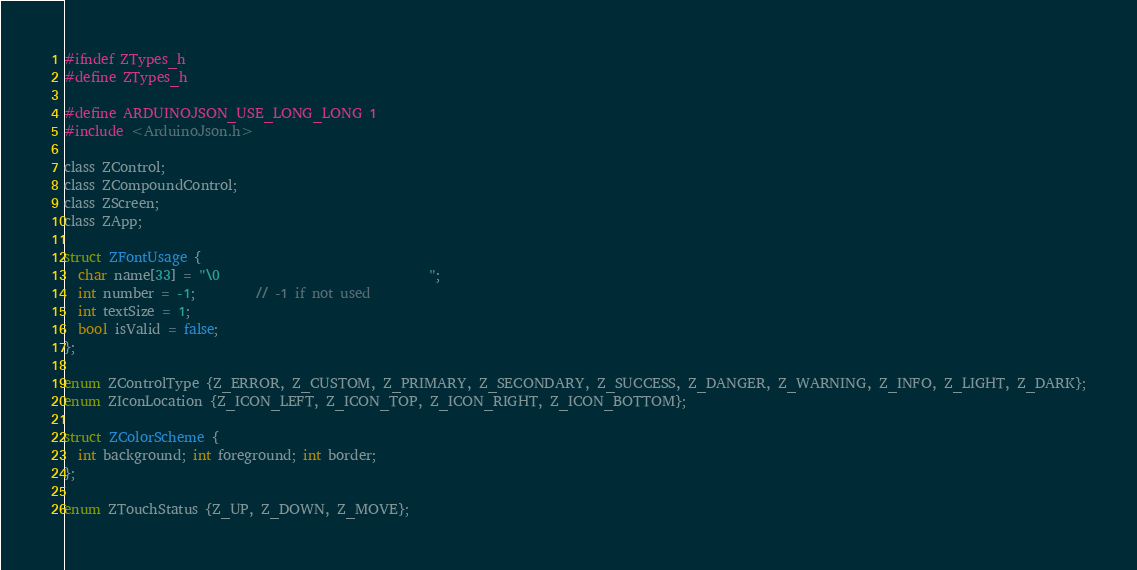<code> <loc_0><loc_0><loc_500><loc_500><_C_>#ifndef ZTypes_h
#define ZTypes_h

#define ARDUINOJSON_USE_LONG_LONG 1
#include <ArduinoJson.h>

class ZControl;
class ZCompoundControl;
class ZScreen;
class ZApp;

struct ZFontUsage {
  char name[33] = "\0                               ";
  int number = -1;         // -1 if not used
  int textSize = 1;
  bool isValid = false;
};

enum ZControlType {Z_ERROR, Z_CUSTOM, Z_PRIMARY, Z_SECONDARY, Z_SUCCESS, Z_DANGER, Z_WARNING, Z_INFO, Z_LIGHT, Z_DARK};
enum ZIconLocation {Z_ICON_LEFT, Z_ICON_TOP, Z_ICON_RIGHT, Z_ICON_BOTTOM};

struct ZColorScheme {
  int background; int foreground; int border;
};

enum ZTouchStatus {Z_UP, Z_DOWN, Z_MOVE};</code> 